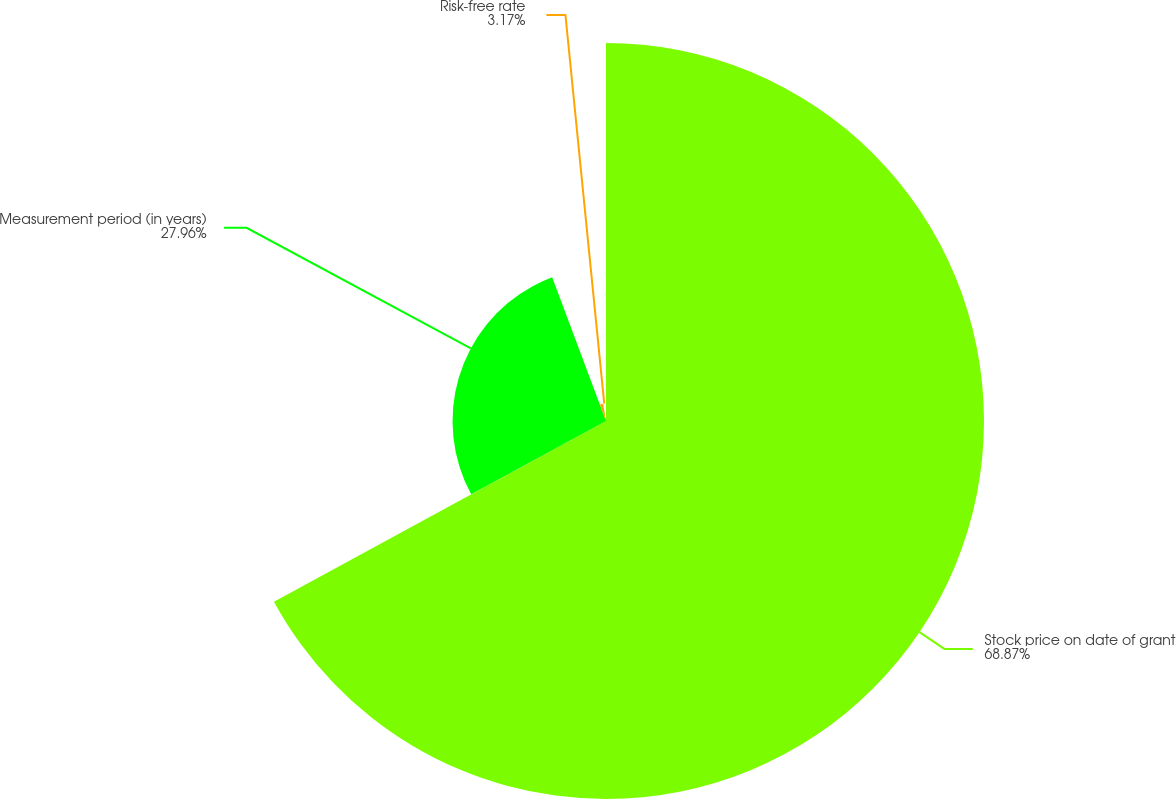<chart> <loc_0><loc_0><loc_500><loc_500><pie_chart><fcel>Stock price on date of grant<fcel>Measurement period (in years)<fcel>Risk-free rate<nl><fcel>68.87%<fcel>27.96%<fcel>3.17%<nl></chart> 